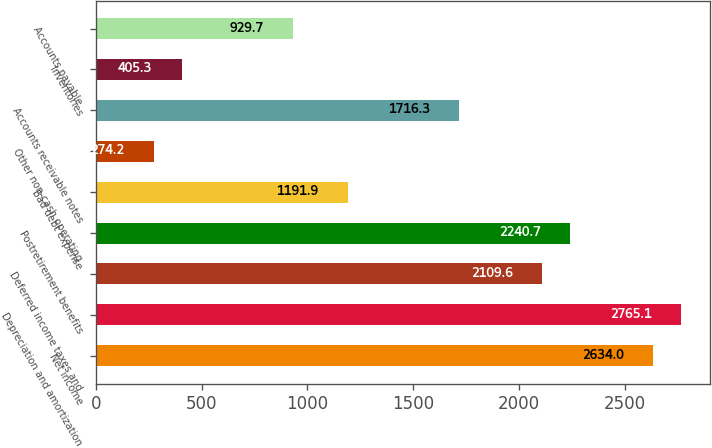Convert chart. <chart><loc_0><loc_0><loc_500><loc_500><bar_chart><fcel>Net income<fcel>Depreciation and amortization<fcel>Deferred income taxes and<fcel>Postretirement benefits<fcel>Bad debt expense<fcel>Other non-cash operating<fcel>Accounts receivable notes<fcel>Inventories<fcel>Accounts payable<nl><fcel>2634<fcel>2765.1<fcel>2109.6<fcel>2240.7<fcel>1191.9<fcel>274.2<fcel>1716.3<fcel>405.3<fcel>929.7<nl></chart> 